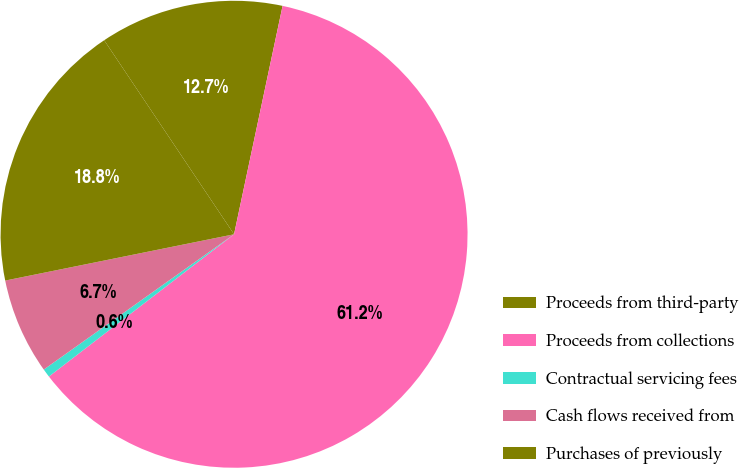Convert chart to OTSL. <chart><loc_0><loc_0><loc_500><loc_500><pie_chart><fcel>Proceeds from third-party<fcel>Proceeds from collections<fcel>Contractual servicing fees<fcel>Cash flows received from<fcel>Purchases of previously<nl><fcel>12.72%<fcel>61.24%<fcel>0.59%<fcel>6.66%<fcel>18.79%<nl></chart> 